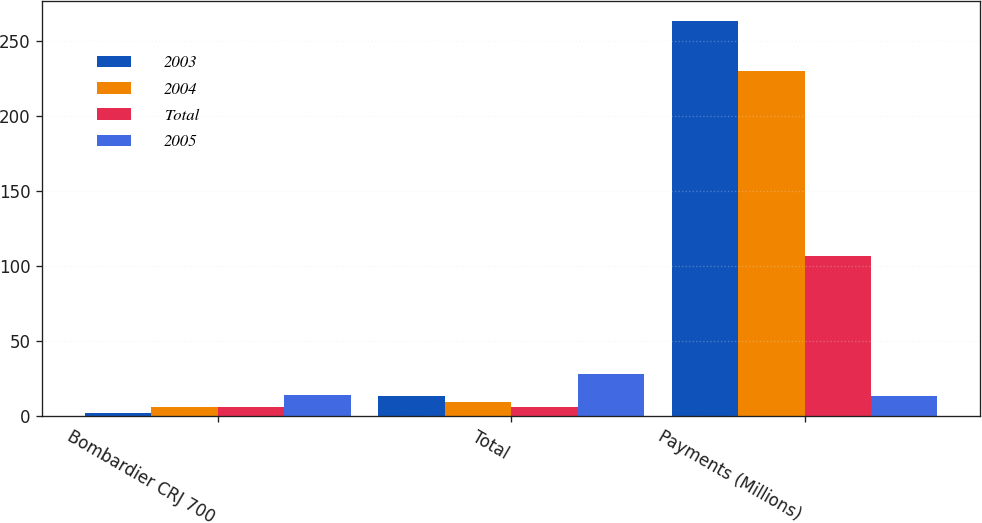<chart> <loc_0><loc_0><loc_500><loc_500><stacked_bar_chart><ecel><fcel>Bombardier CRJ 700<fcel>Total<fcel>Payments (Millions)<nl><fcel>2003<fcel>2<fcel>13<fcel>264<nl><fcel>2004<fcel>6<fcel>9<fcel>230<nl><fcel>Total<fcel>6<fcel>6<fcel>107<nl><fcel>2005<fcel>14<fcel>28<fcel>13<nl></chart> 